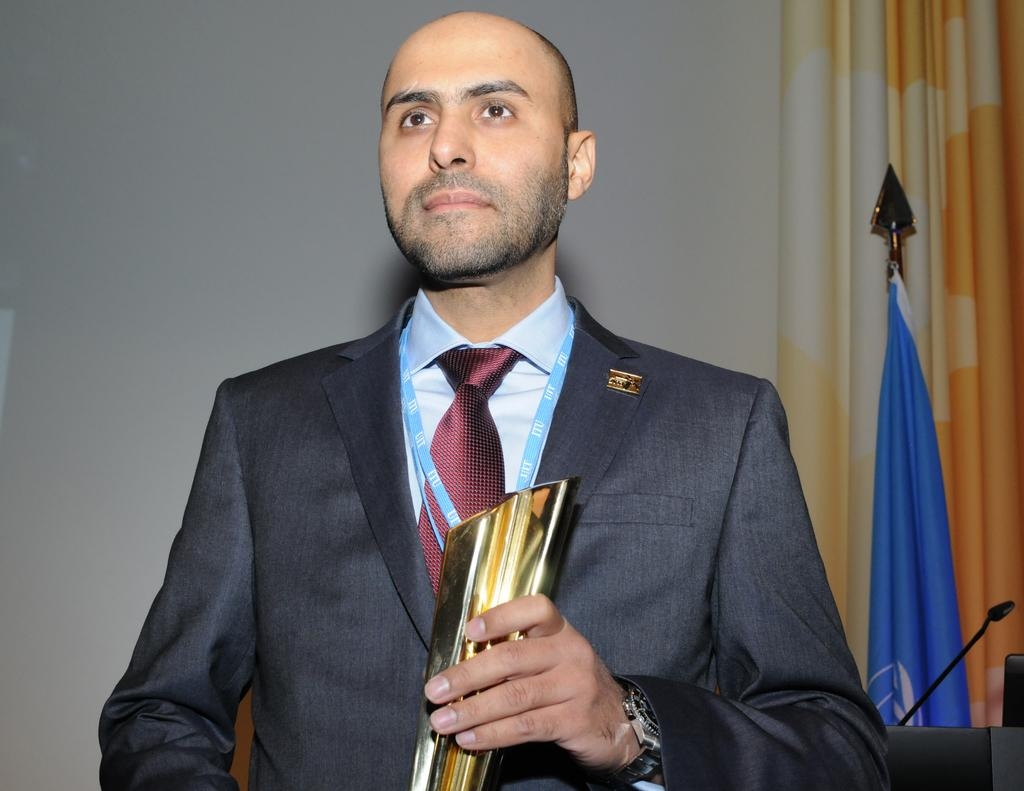What can be seen in the image? There is a person in the image. What is the person holding? The person is holding something. Can you describe any other objects in the image? There is a microphone (mike) on the right side of the image. Can you tell me how many zebras are visible in the image? There are no zebras present in the image. What type of gun is the person holding in the image? The person is not holding a gun in the image; they are holding something else. 